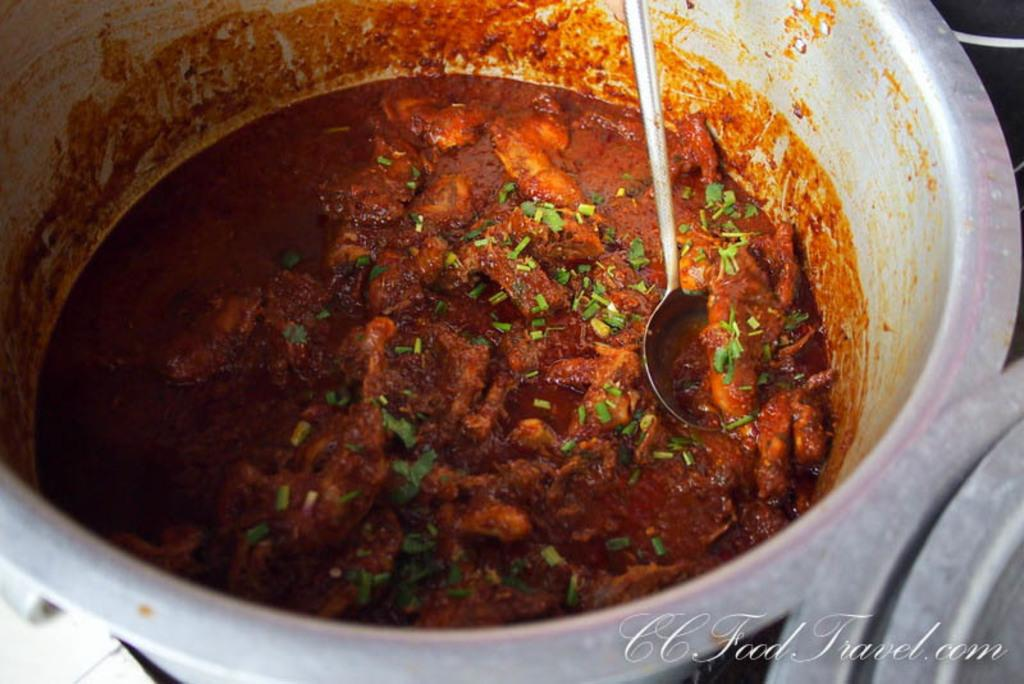What type of food is visible in the image? There is a meat curry in the image. Can you describe the object in the vessel? Unfortunately, the facts provided do not give enough information to describe the object in the vessel. Is there any additional information or marking in the image? Yes, there is a watermark in the bottom right corner of the image. What type of stitch is used by the writer in the image? There is no writer or stitching present in the image; it features a meat curry and an object in a vessel with a watermark. 